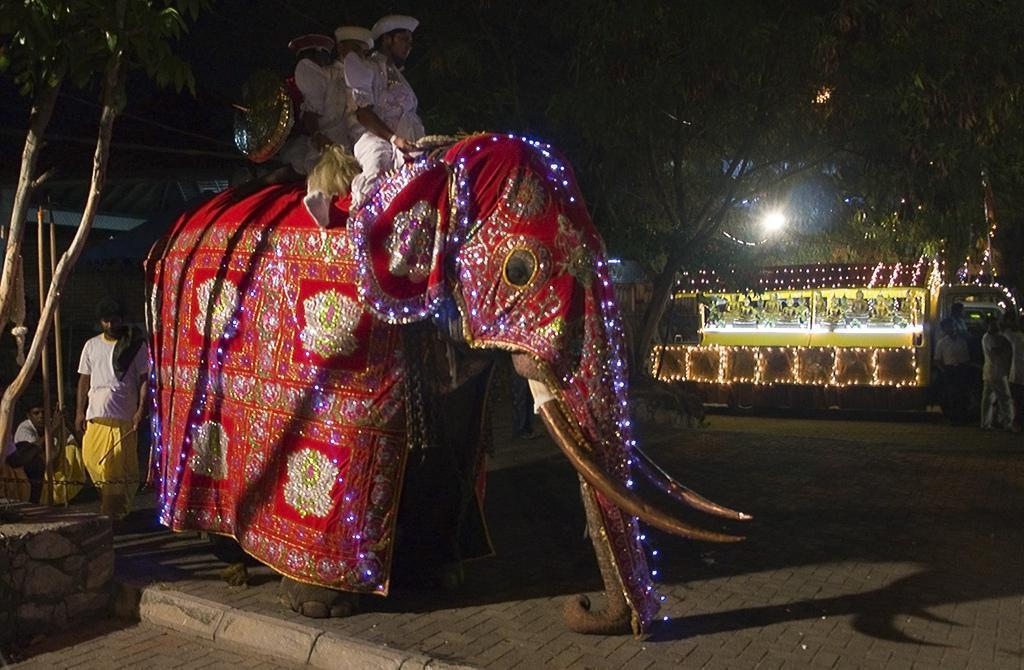How many people are riding the elephant?
Give a very brief answer. 3. How many people are on top of the elephants?
Give a very brief answer. 3. How many tusks are there?
Give a very brief answer. 2. How many tusks does the elephant have?
Give a very brief answer. 2. How many men are on top of the elephant?
Give a very brief answer. 3. How many people are wearing yellow skirts?
Give a very brief answer. 1. 